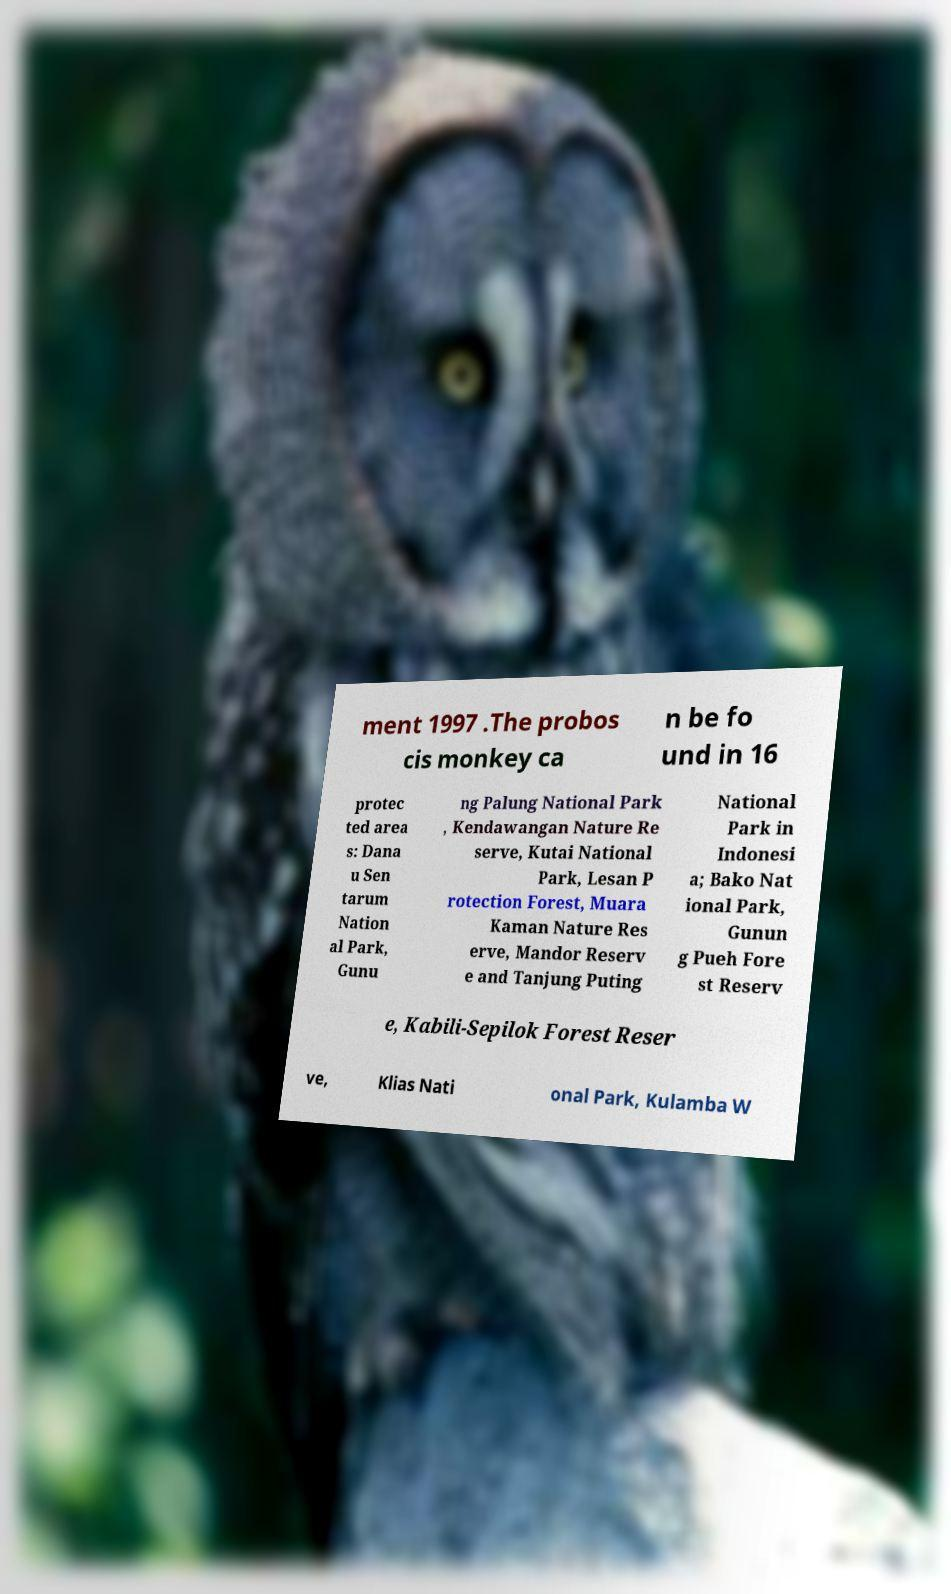I need the written content from this picture converted into text. Can you do that? ment 1997 .The probos cis monkey ca n be fo und in 16 protec ted area s: Dana u Sen tarum Nation al Park, Gunu ng Palung National Park , Kendawangan Nature Re serve, Kutai National Park, Lesan P rotection Forest, Muara Kaman Nature Res erve, Mandor Reserv e and Tanjung Puting National Park in Indonesi a; Bako Nat ional Park, Gunun g Pueh Fore st Reserv e, Kabili-Sepilok Forest Reser ve, Klias Nati onal Park, Kulamba W 